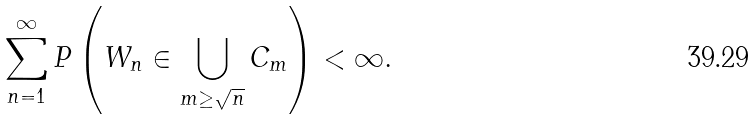<formula> <loc_0><loc_0><loc_500><loc_500>\sum _ { n = 1 } ^ { \infty } P \left ( W _ { n } \in \bigcup _ { m \geq \sqrt { n } } C _ { m } \right ) < \infty .</formula> 